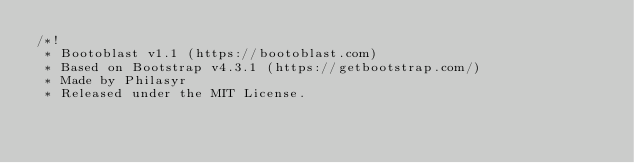<code> <loc_0><loc_0><loc_500><loc_500><_CSS_>/*!
 * Bootoblast v1.1 (https://bootoblast.com)
 * Based on Bootstrap v4.3.1 (https://getbootstrap.com/)
 * Made by Philasyr
 * Released under the MIT License.</code> 